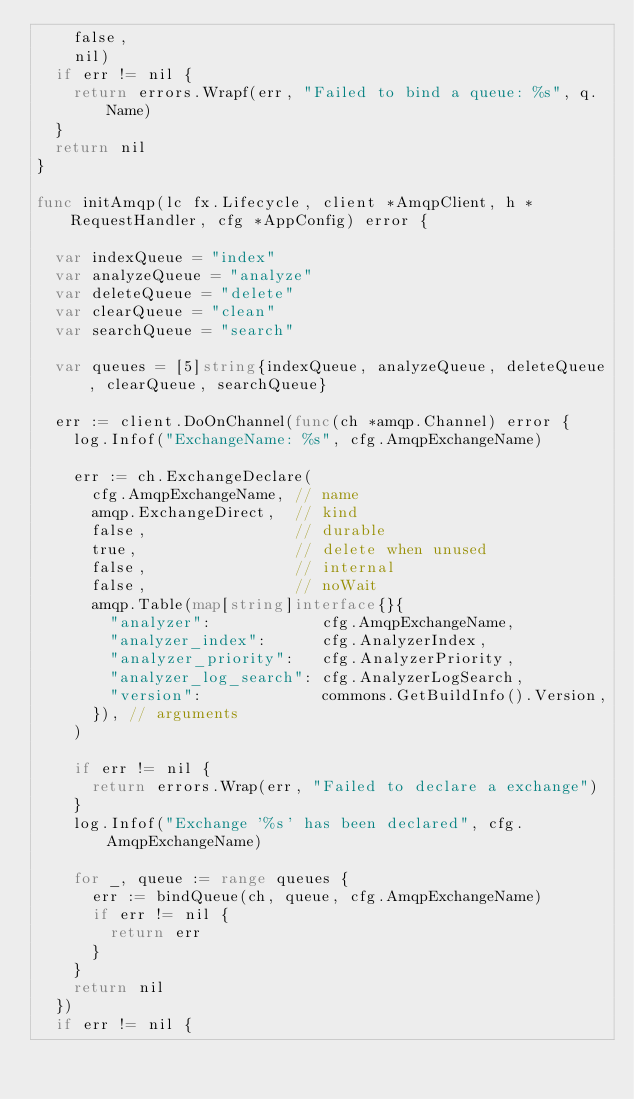<code> <loc_0><loc_0><loc_500><loc_500><_Go_>		false,
		nil)
	if err != nil {
		return errors.Wrapf(err, "Failed to bind a queue: %s", q.Name)
	}
	return nil
}

func initAmqp(lc fx.Lifecycle, client *AmqpClient, h *RequestHandler, cfg *AppConfig) error {

	var indexQueue = "index"
	var analyzeQueue = "analyze"
	var deleteQueue = "delete"
	var clearQueue = "clean"
	var searchQueue = "search"

	var queues = [5]string{indexQueue, analyzeQueue, deleteQueue, clearQueue, searchQueue}

	err := client.DoOnChannel(func(ch *amqp.Channel) error {
		log.Infof("ExchangeName: %s", cfg.AmqpExchangeName)

		err := ch.ExchangeDeclare(
			cfg.AmqpExchangeName, // name
			amqp.ExchangeDirect,  // kind
			false,                // durable
			true,                 // delete when unused
			false,                // internal
			false,                // noWait
			amqp.Table(map[string]interface{}{
				"analyzer":            cfg.AmqpExchangeName,
				"analyzer_index":      cfg.AnalyzerIndex,
				"analyzer_priority":   cfg.AnalyzerPriority,
				"analyzer_log_search": cfg.AnalyzerLogSearch,
				"version":             commons.GetBuildInfo().Version,
			}), // arguments
		)

		if err != nil {
			return errors.Wrap(err, "Failed to declare a exchange")
		}
		log.Infof("Exchange '%s' has been declared", cfg.AmqpExchangeName)

		for _, queue := range queues {
			err := bindQueue(ch, queue, cfg.AmqpExchangeName)
			if err != nil {
				return err
			}
		}
		return nil
	})
	if err != nil {</code> 